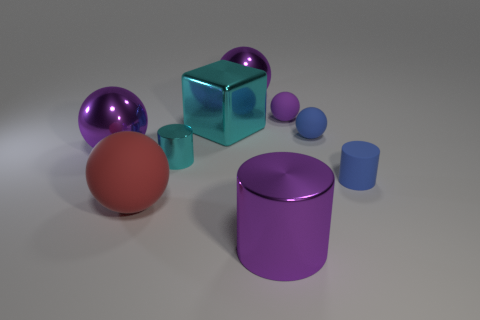Subtract all purple balls. How many were subtracted if there are1purple balls left? 2 Subtract all small cylinders. How many cylinders are left? 1 Subtract all blue balls. How many balls are left? 4 Add 1 purple cylinders. How many objects exist? 10 Subtract 1 balls. How many balls are left? 4 Subtract all balls. How many objects are left? 4 Subtract all gray cubes. Subtract all cyan spheres. How many cubes are left? 1 Subtract all small purple things. Subtract all big red spheres. How many objects are left? 7 Add 2 purple matte spheres. How many purple matte spheres are left? 3 Add 4 big shiny spheres. How many big shiny spheres exist? 6 